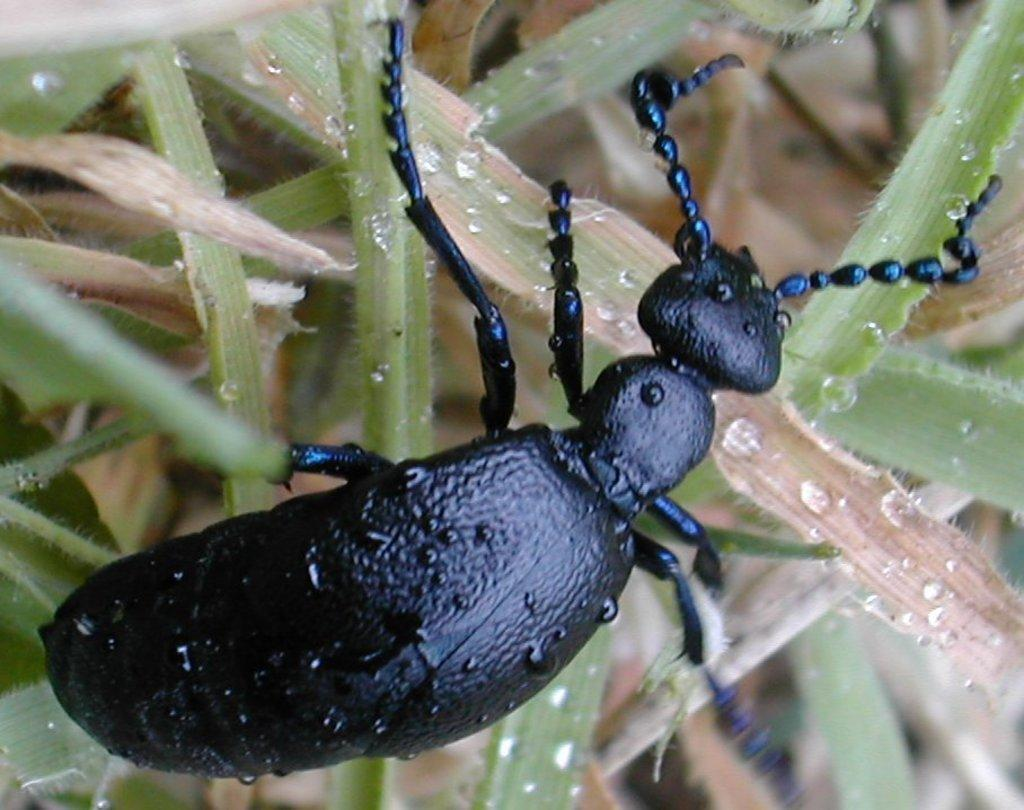What type of creature can be seen in the image? There is an insect in the image. Where is the insect located in the image? The insect is on the plants. What attempt does the minister make in the image? There is no minister or attempt present in the image; it features an insect on plants. How does the snow affect the insect in the image? There is no snow present in the image, so its effect on the insect cannot be determined. 